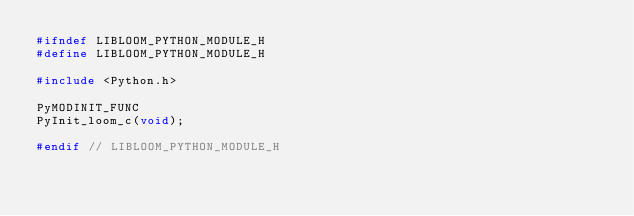<code> <loc_0><loc_0><loc_500><loc_500><_C_>#ifndef LIBLOOM_PYTHON_MODULE_H
#define LIBLOOM_PYTHON_MODULE_H

#include <Python.h>

PyMODINIT_FUNC
PyInit_loom_c(void);

#endif // LIBLOOM_PYTHON_MODULE_H
</code> 